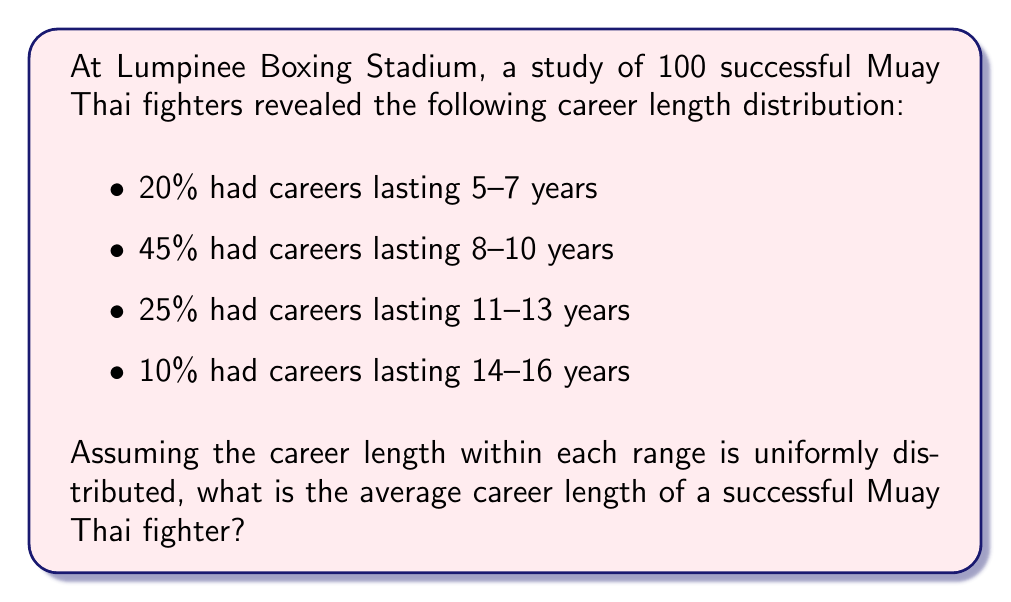Give your solution to this math problem. To solve this problem, we'll follow these steps:

1) First, let's calculate the midpoint of each range:
   - 5-7 years: $(5+7)/2 = 6$ years
   - 8-10 years: $(8+10)/2 = 9$ years
   - 11-13 years: $(11+13)/2 = 12$ years
   - 14-16 years: $(14+16)/2 = 15$ years

2) Now, we'll set up the expected value formula:
   $$E(X) = \sum_{i=1}^{n} x_i \cdot p(x_i)$$
   where $x_i$ is each midpoint and $p(x_i)$ is its probability.

3) Plugging in our values:
   $$E(X) = 6 \cdot 0.20 + 9 \cdot 0.45 + 12 \cdot 0.25 + 15 \cdot 0.10$$

4) Calculate:
   $$E(X) = 1.2 + 4.05 + 3 + 1.5 = 9.75$$

Therefore, the average career length of a successful Muay Thai fighter is 9.75 years.
Answer: 9.75 years 